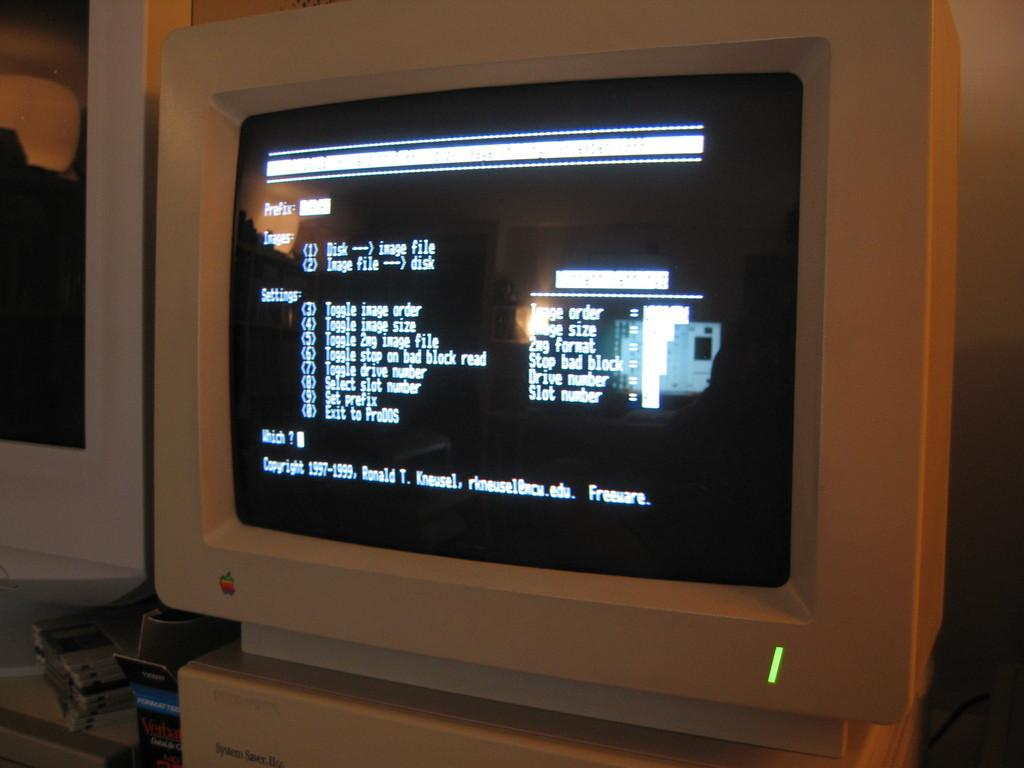<image>
Give a short and clear explanation of the subsequent image. apple computer with options on the screen to do an image file 